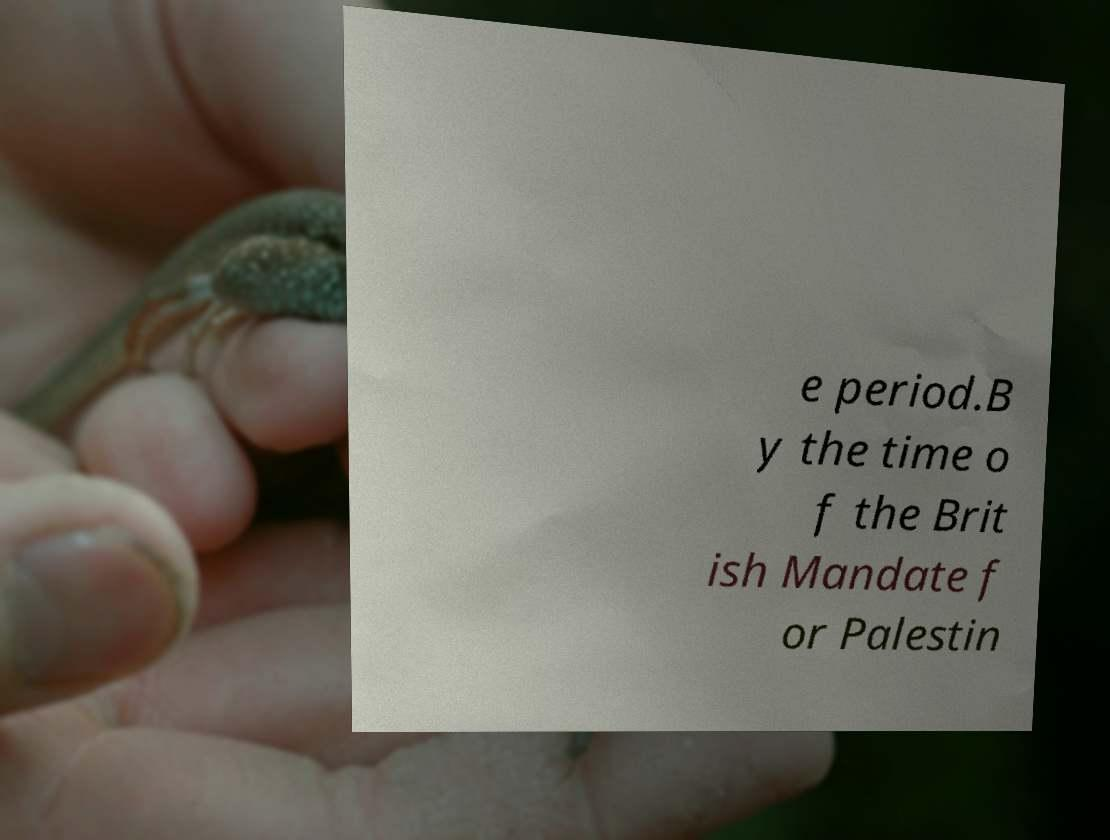Please read and relay the text visible in this image. What does it say? e period.B y the time o f the Brit ish Mandate f or Palestin 